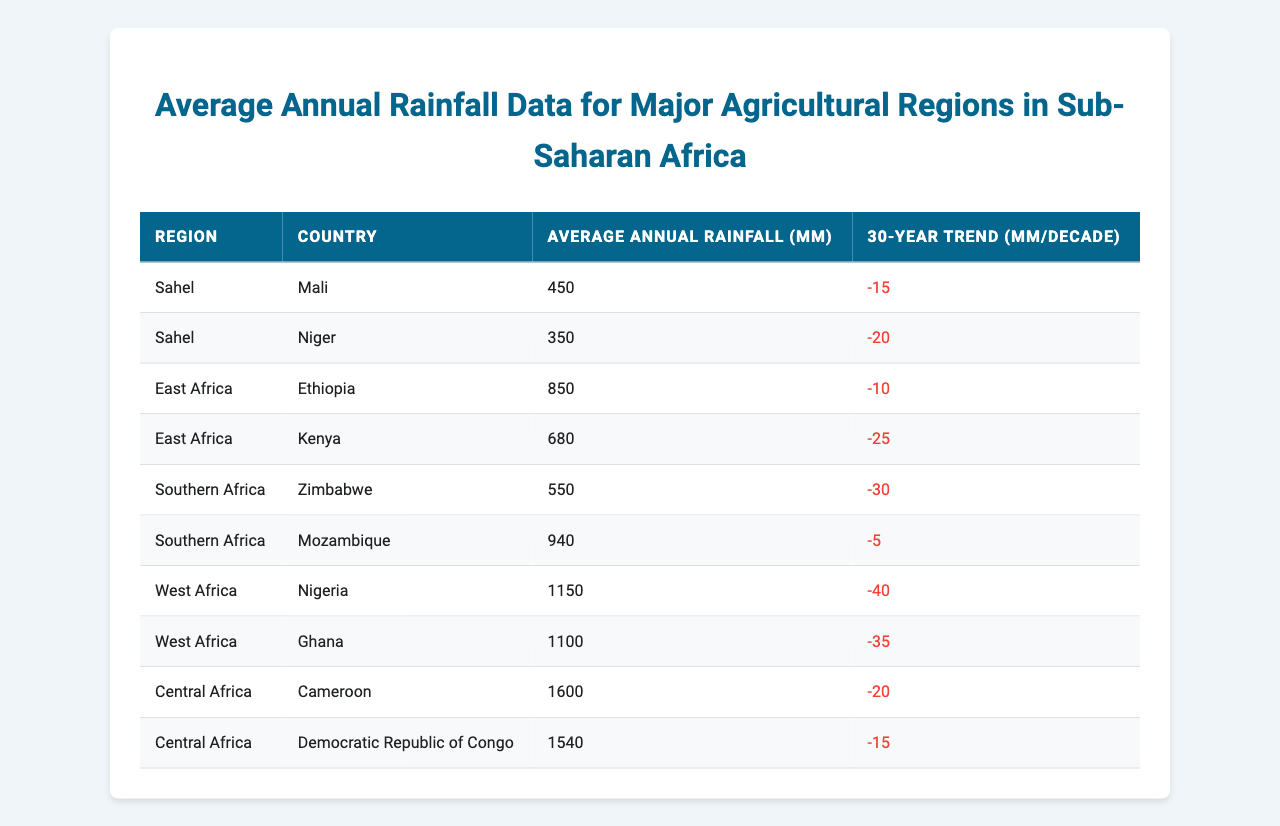What is the average annual rainfall in Nigeria? The table indicates that Nigeria has an average annual rainfall of 1150 mm.
Answer: 1150 mm Which region has the highest average annual rainfall? By examining the table, Cameroon from Central Africa shows the highest average annual rainfall at 1600 mm.
Answer: 1600 mm What is the 30-year trend in average annual rainfall for Kenya? The table shows that Kenya has a negative trend of -25 mm/decade, indicating a decrease in rainfall over the last 30 years.
Answer: -25 mm/decade How does the average annual rainfall in Mali compare to that in Mozambique? Mali's average annual rainfall is 450 mm and Mozambique's is 940 mm. Subtracting these values shows that Mozambique has 490 mm more rainfall than Mali.
Answer: 490 mm more Is the average annual rainfall for Ghana greater than 1000 mm? The table shows Ghana's average annual rainfall is 1100 mm, which is greater than 1000 mm.
Answer: Yes What is the combined average annual rainfall of the agricultural regions in the Sahel? The average annual rainfall for Mali is 450 mm and for Niger is 350 mm. Adding these gives a combined total of 800 mm.
Answer: 800 mm Which countries in West Africa have a decreasing trend in average annual rainfall? The data shows that both Nigeria (-40 mm/decade) and Ghana (-35 mm/decade) have a decreasing trend in rainfall.
Answer: Nigeria and Ghana What is the total decrease in average annual rainfall across all regions over the past 30 years? To determine the total decrease, sum the trends: -15 (Mali) + -20 (Niger) + -10 (Ethiopia) + -25 (Kenya) + -30 (Zimbabwe) + -5 (Mozambique) + -40 (Nigeria) + -35 (Ghana) + -20 (Cameroon) + -15 (DR Congo) = - 230 mm/decade.
Answer: -230 mm/decade Which region has the lowest average annual rainfall and what is that value? The table shows that the Sahel region has the lowest average rainfall, with Mali at 450 mm and Niger at 350 mm. Therefore, Niger has the lowest average annual rainfall of 350 mm.
Answer: 350 mm What is the average annual rainfall for Central Africa? Central Africa has Cameroon at 1600 mm and the Democratic Republic of Congo at 1540 mm. Adding these gives a total of 3140 mm, and dividing by 2 (the number of countries) results in an average of 1570 mm.
Answer: 1570 mm 